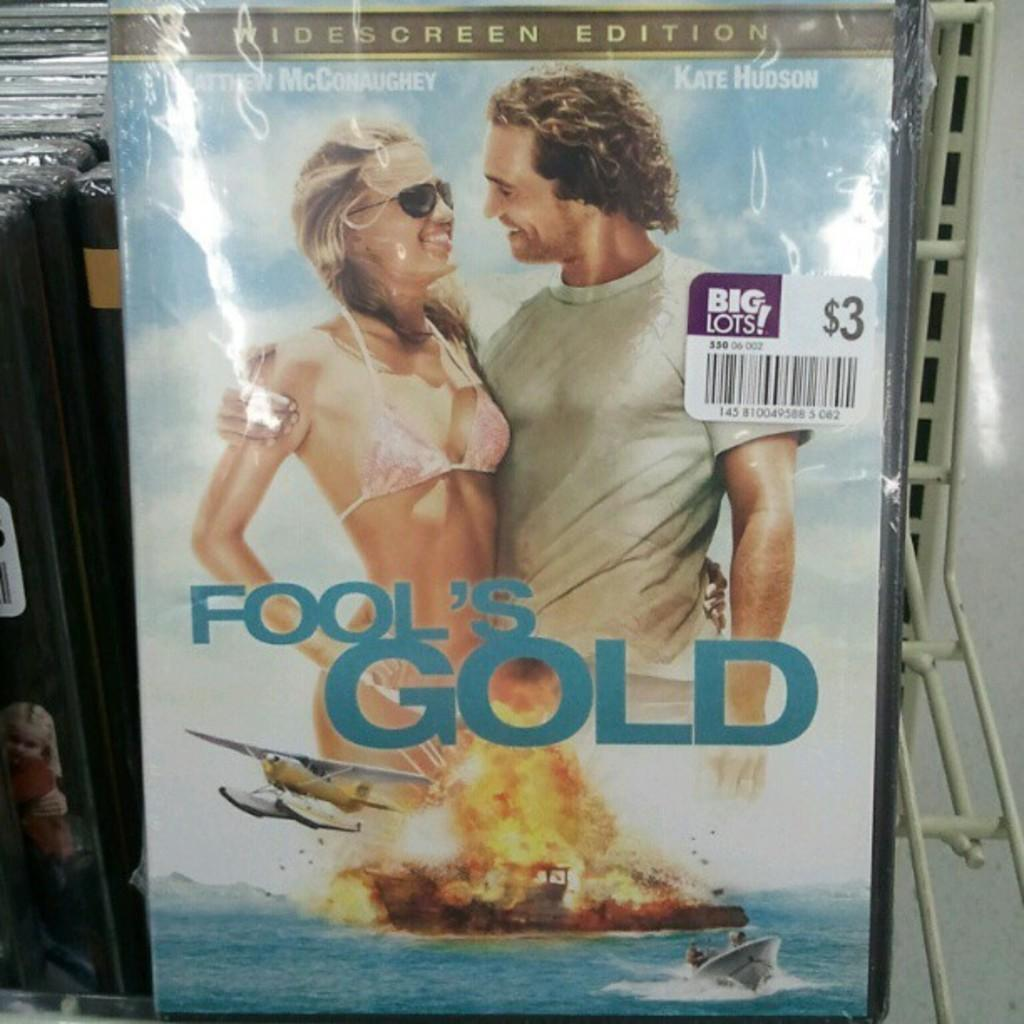<image>
Relay a brief, clear account of the picture shown. DVD cover for Fool's Gold starring Kate Hudson on sale at Big Lots. 